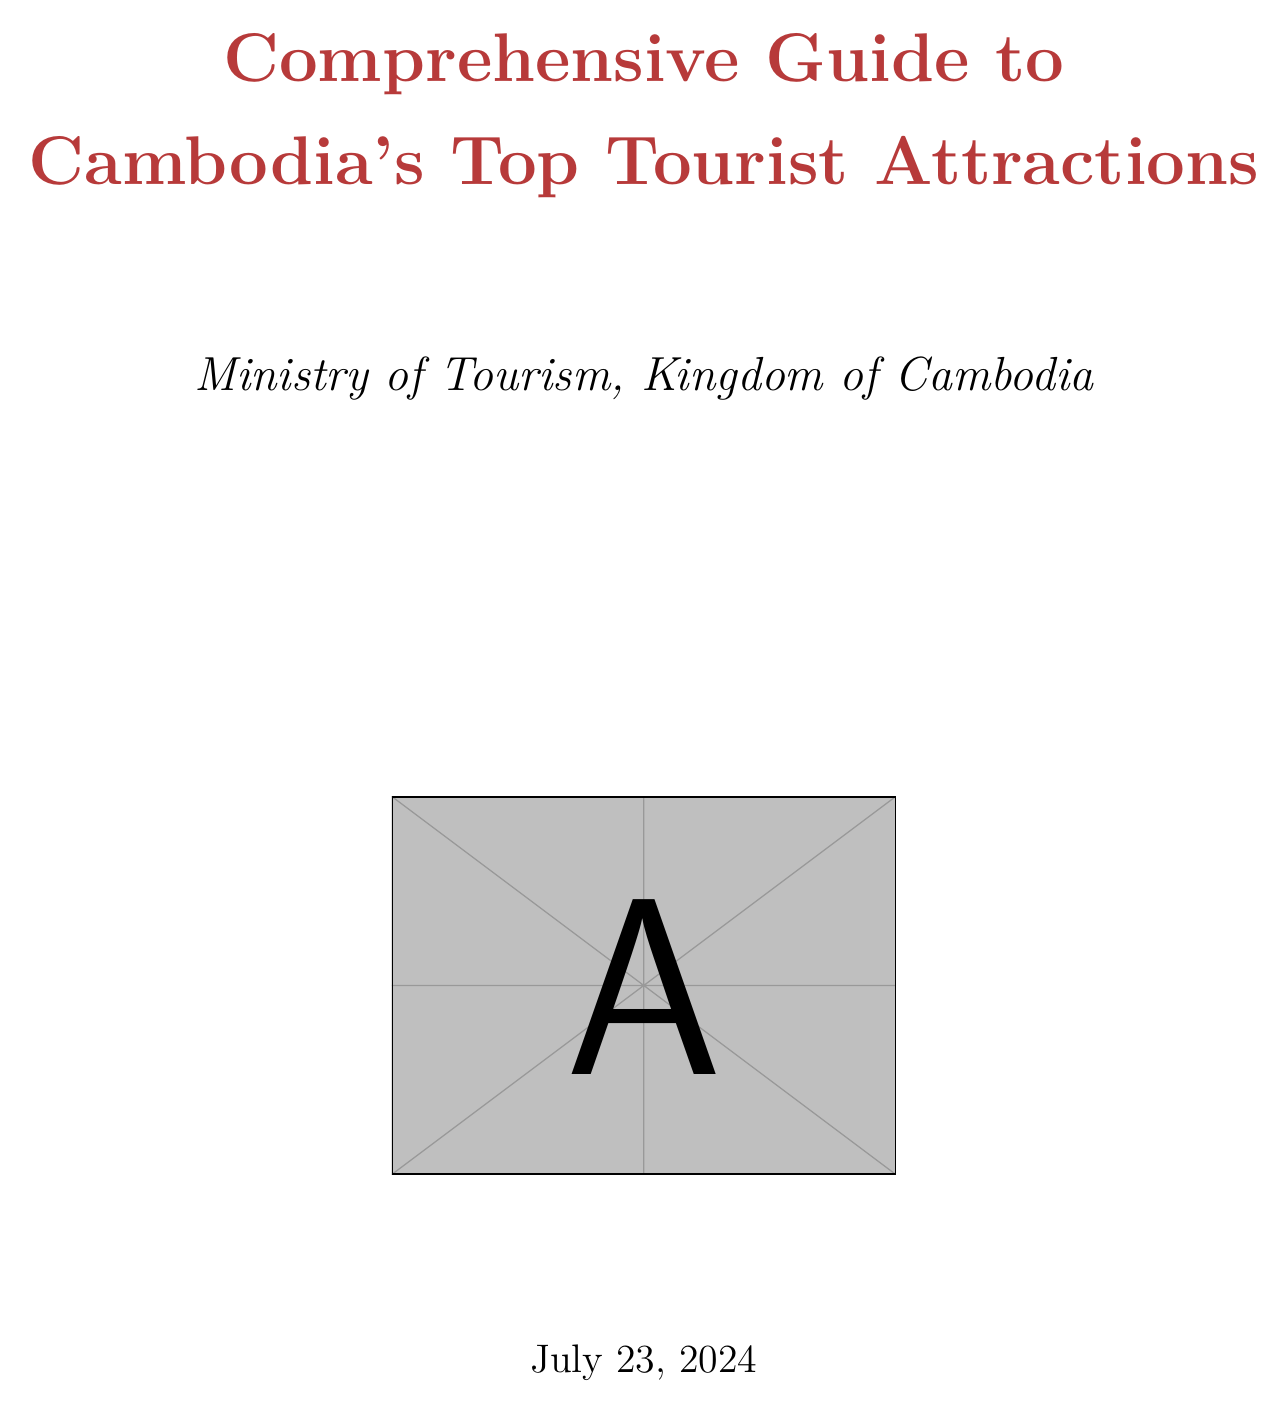What is the entrance fee for Angkor Archaeological Park? The entrance fee for Angkor Archaeological Park is stated in the visitor information section.
Answer: $37 for a one-day pass What time does the Royal Palace open? The opening hours for the Royal Palace are specified under visitor information.
Answer: 8:00 AM What activities can be enjoyed at Tonlé Sap Lake? The document lists activities for Tonlé Sap Lake in the visitor information section.
Answer: Boat tours, Bird watching, Floating village visits What is the best time to visit Koh Rong Island? The best time to visit Koh Rong Island is found in the visitor information for that location.
Answer: Not specified How much does a ticket to Phare, The Cambodian Circus cost? The ticket prices for Phare, The Cambodian Circus are mentioned in its visitor information.
Answer: From $18 to $38 How long do Siem Reap Food Tours last? The duration of Siem Reap Food Tours is provided in the visitor information section.
Answer: 3-4 hours What is required for a tourist visa? The required documents for a tourist visa are listed in the practical information section.
Answer: Valid passport, Passport-sized photo, Completed visa application form What are the local customs regarding dress when visiting religious sites? The local customs regarding dress are detailed in the practical information section.
Answer: Dress modestly when visiting religious sites What does the overview map provide? The document specifies that the overview map is among the maps listed.
Answer: URL to Cambodia overview map 